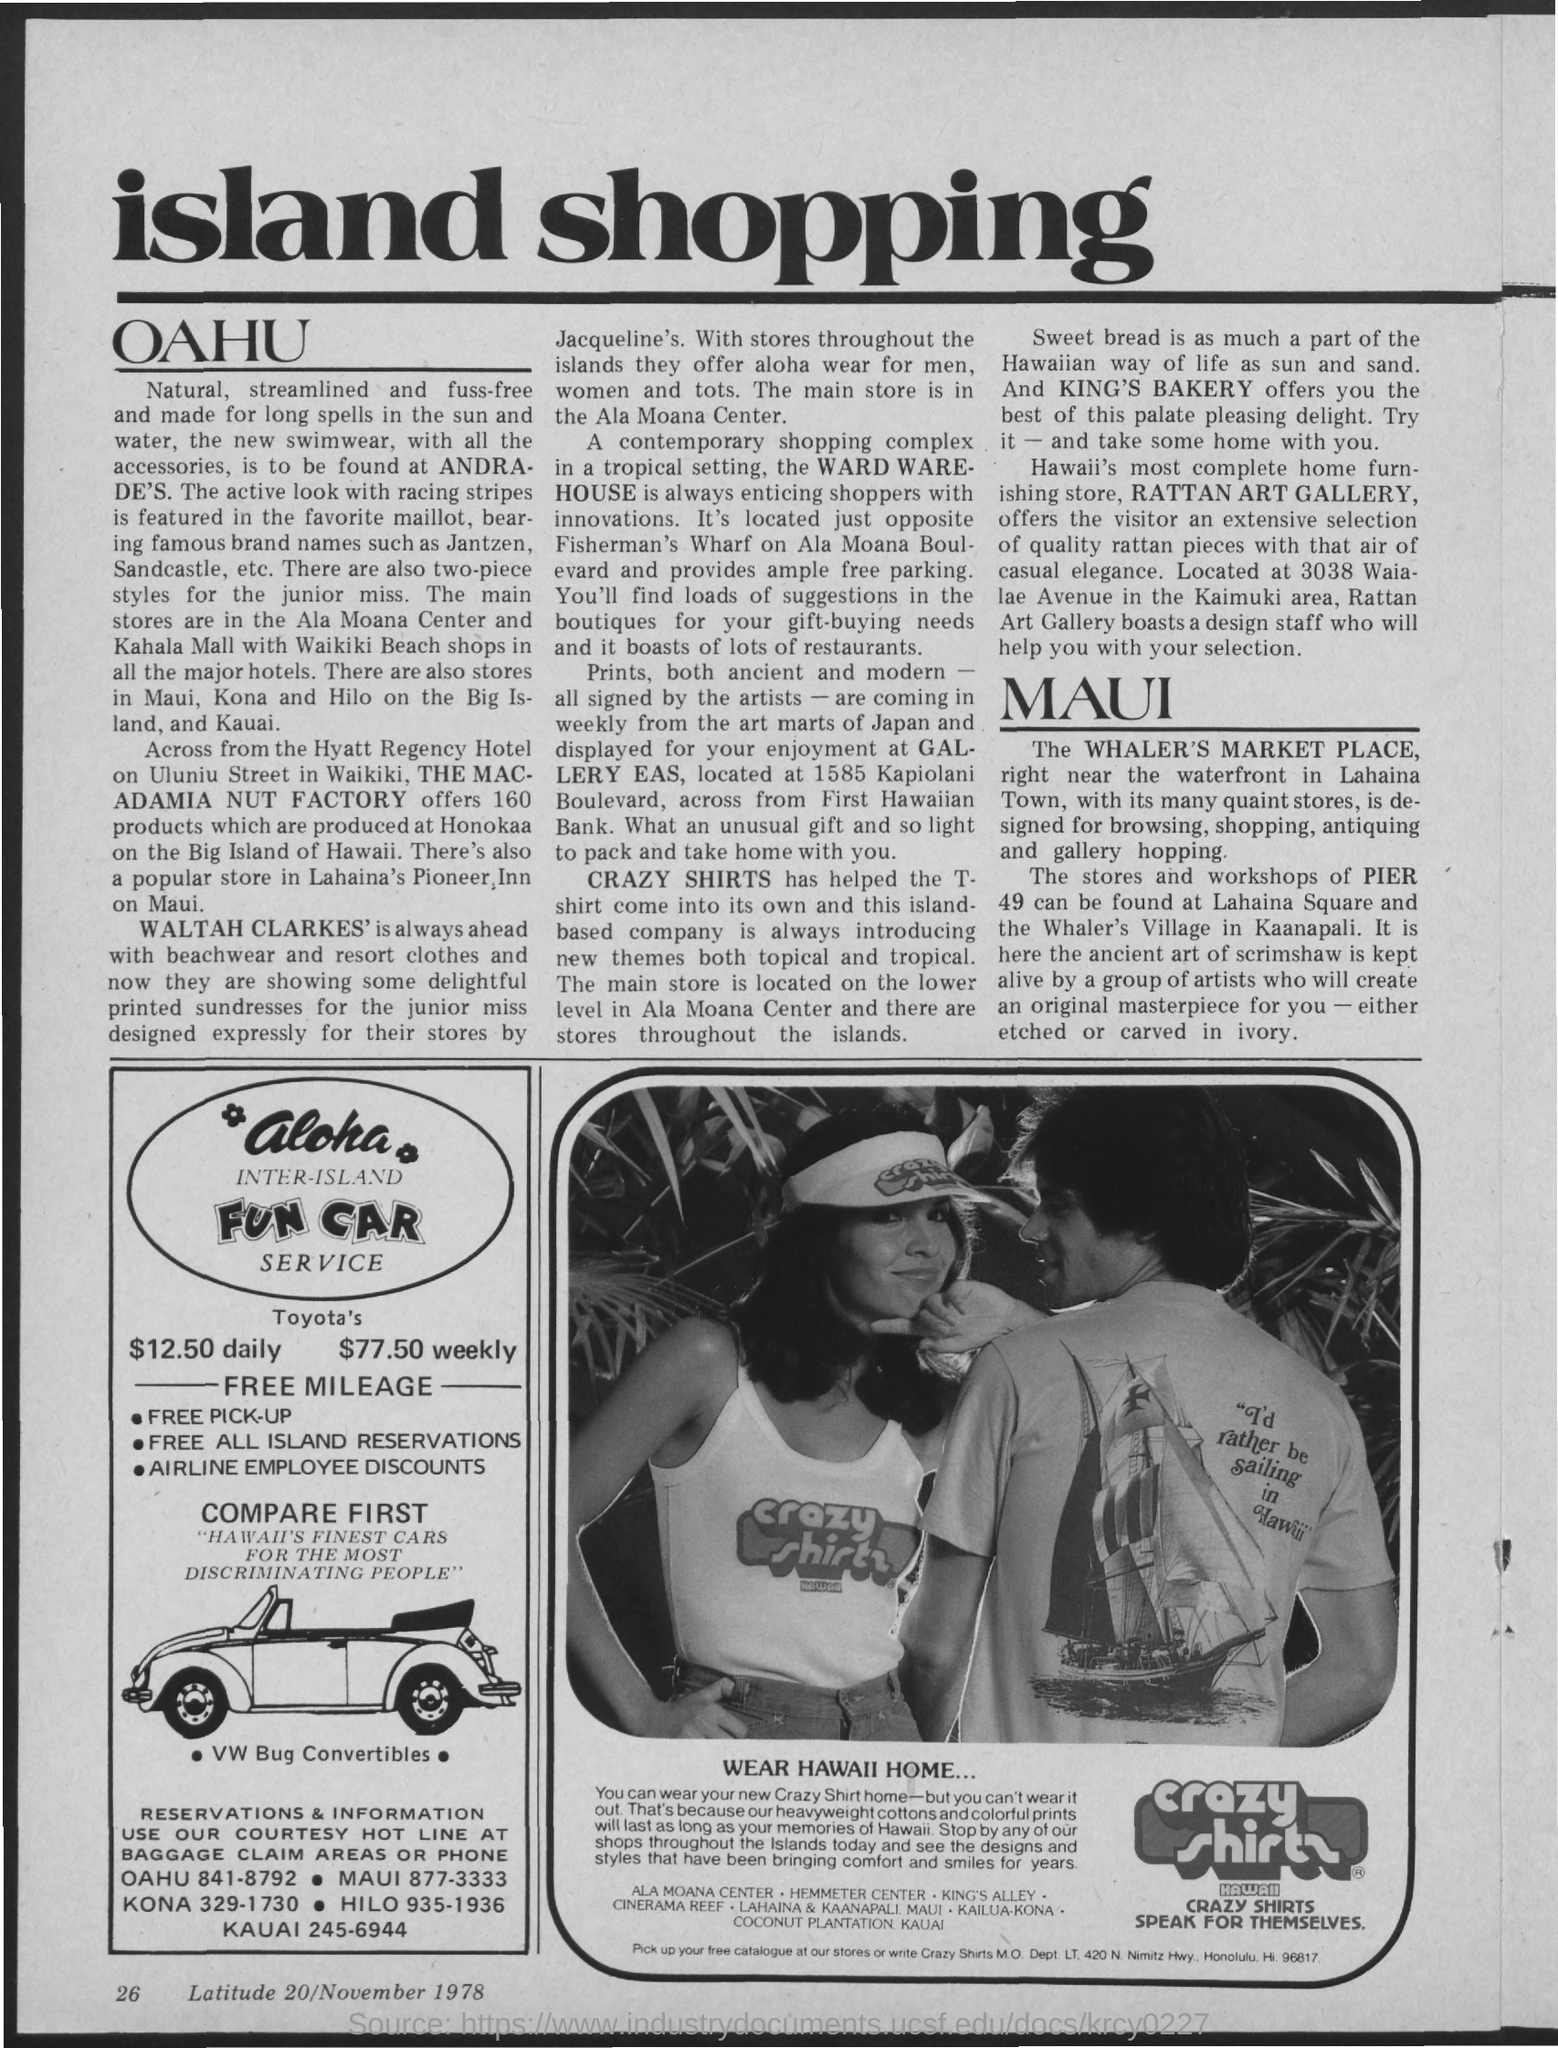What is the heading of the document on top of page?
Your response must be concise. Island shopping. What is the postal code of hi?
Your answer should be very brief. 96817. What is the postal address of crazy shirts?
Your answer should be very brief. Crazy shirts m.o. dept. lt, 420 n. nimitz hwy., honolulu, hi. 96817. 